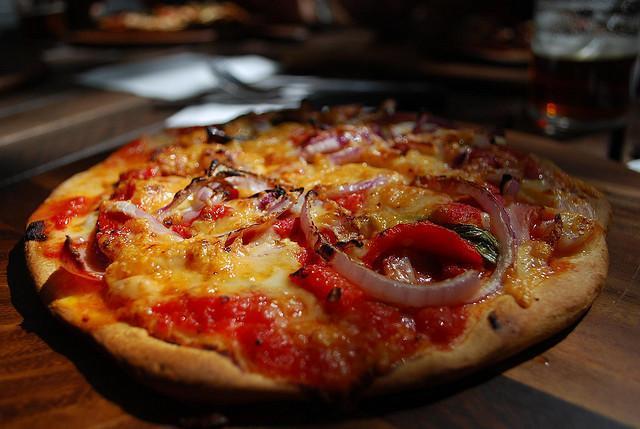The white round item on top of this food is part of what other food item?
Choose the correct response and explain in the format: 'Answer: answer
Rationale: rationale.'
Options: Flounder, tuna, onion rings, calamari. Answer: onion rings.
Rationale: These are onions, and onion rings are made out of the same thing, just covered in batter. 